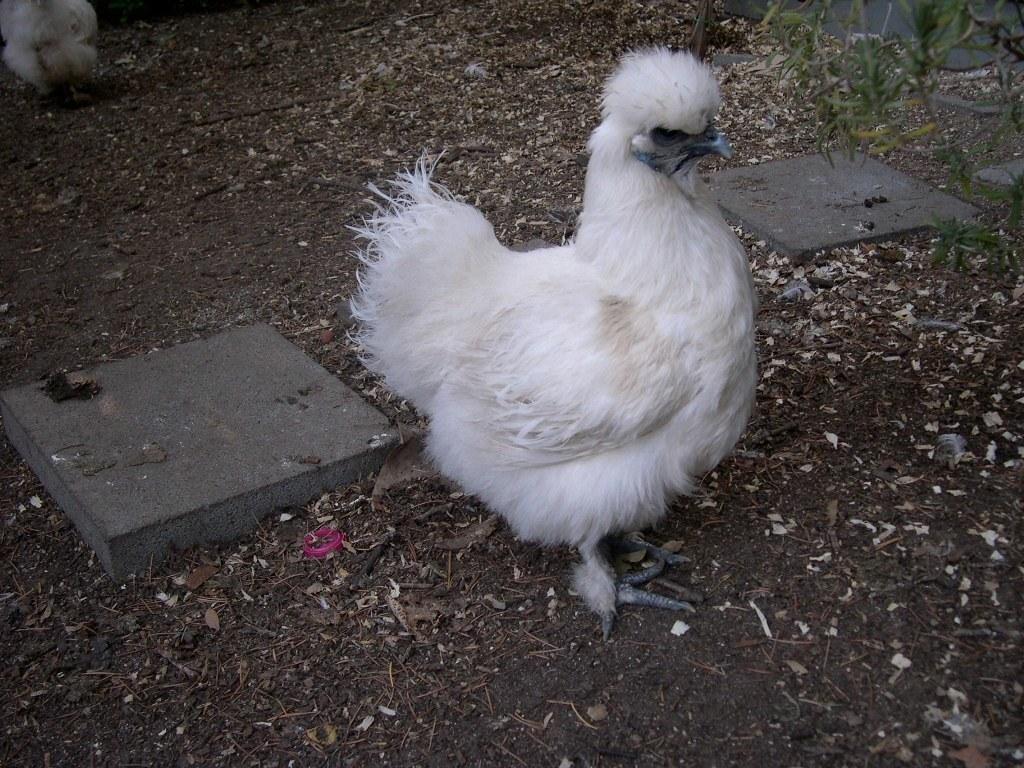In one or two sentences, can you explain what this image depicts? There is a white color hen standing on the ground on which, there are small sticks, stones and other objects. On both sides of thighs when, there is a slab. In the background, there is another hen on the ground. 